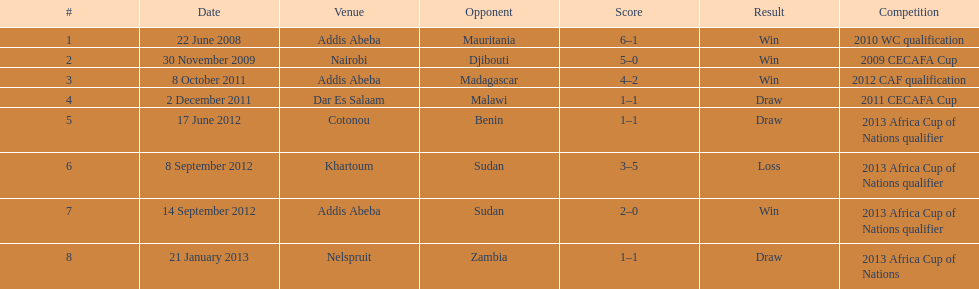What is the longevity in years of this table cover? 5. 